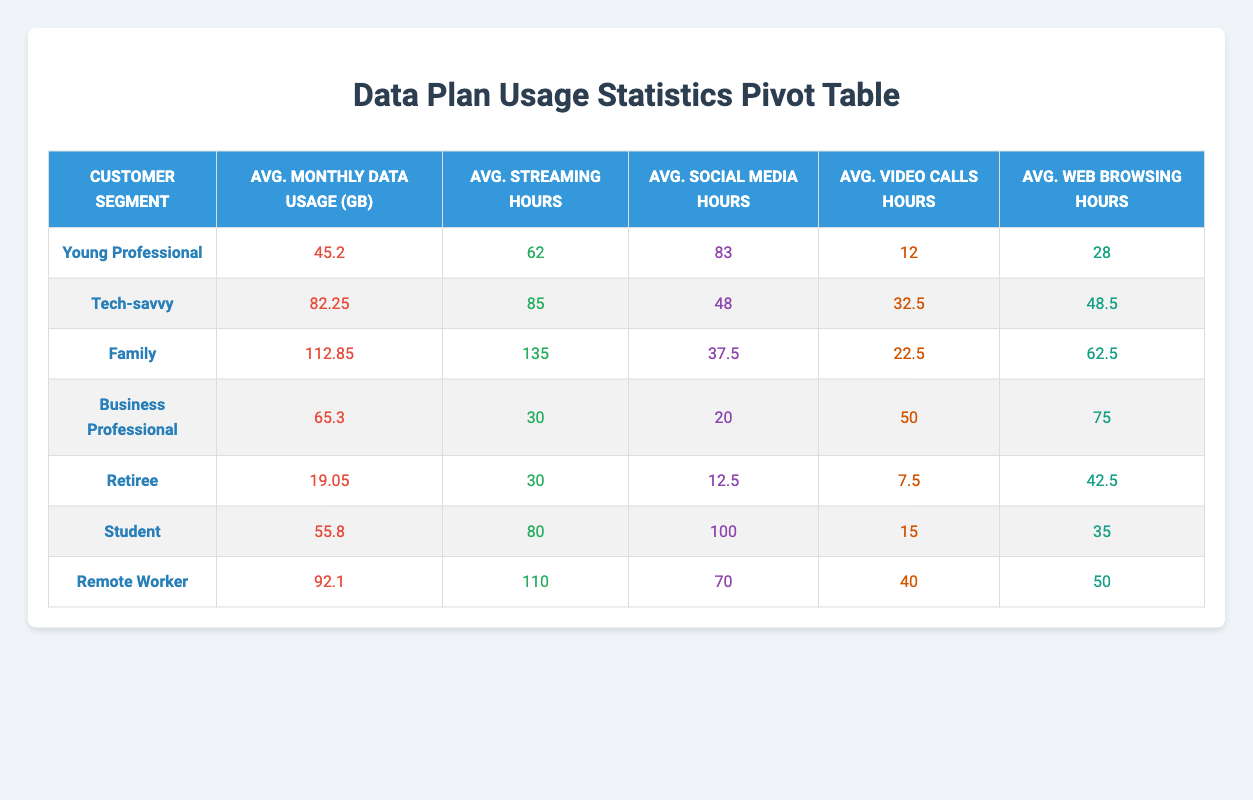What is the average monthly data usage for the Tech-savvy segment? To find the average monthly data usage for the Tech-savvy segment, we need to look at the two entries: C1002 (78.9 GB) and C1008 (85.6 GB). We sum these values: 78.9 + 85.6 = 164.5 GB. Then, we divide by the number of entries (2): 164.5 / 2 = 82.25 GB.
Answer: 82.25 GB Which customer segment has the highest average streaming hours? By examining the average streaming hours column, we see that the Family segment has 135 hours, which is higher than any other segment listed in the table.
Answer: Family Is the average data usage for Retirees greater than 20 GB? The average monthly data usage for the Retiree segment is 19.05 GB, which is less than 20 GB. Therefore, the answer is no.
Answer: No What is the total average web browsing hours for all segments combined? First, we sum the average web browsing hours: 28 + 48.5 + 62.5 + 75 + 42.5 + 35 + 50 = 341.5 hours. Then, we divide by the number of segments (7): 341.5 / 7 = 48.785 hours. Rounding to two decimal places, the total is approximately 48.79 hours.
Answer: 48.79 hours Which customer segments have average social media hours less than 50? We look at the average social media hours: Young Professional (83), Tech-savvy (48), Family (37.5), Business Professional (20), Retiree (12.5), Student (100), and Remote Worker (70). Only the Tech-savvy and Family segments have less than 50 hours: Tech-savvy (48) and Family (37.5).
Answer: Tech-savvy and Family What is the difference in average monthly data usage between Business Professionals and Young Professionals? The average monthly data usage for Business Professionals is 65.3 GB, and for Young Professionals, it is 45.2 GB. To find the difference, we subtract these two values: 65.3 - 45.2 = 20.1 GB.
Answer: 20.1 GB How many segments have an average of more than 90 streaming hours? We analyze the streaming hours: Young Professional (62), Tech-savvy (85), Family (135), Business Professional (30), Retiree (30), Student (80), and Remote Worker (110). The segments with more than 90 streaming hours are Family (135) and Remote Worker (110). Thus, there are 2 segments.
Answer: 2 What is the average of the average video call hours across all segments? The average video call hours are: 12 (Young Professional), 32.5 (Tech-savvy), 22.5 (Family), 50 (Business Professional), 7.5 (Retiree), 15 (Student), and 40 (Remote Worker). Summing these gives us 12 + 32.5 + 22.5 + 50 + 7.5 + 15 + 40 = 180. The number of segments is 7, so we divide: 180 / 7 = 25.714. Rounding gives us approximately 25.71 hours.
Answer: 25.71 hours 